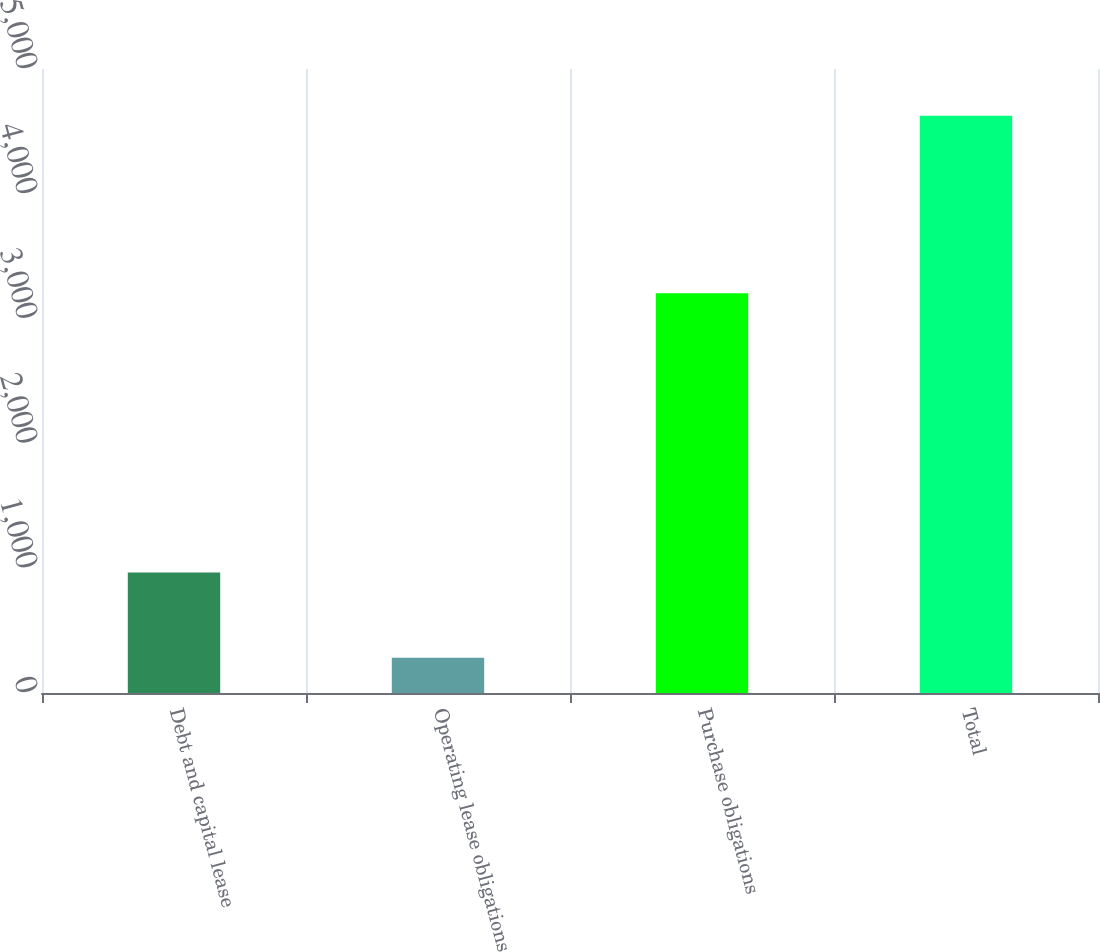Convert chart. <chart><loc_0><loc_0><loc_500><loc_500><bar_chart><fcel>Debt and capital lease<fcel>Operating lease obligations<fcel>Purchase obligations<fcel>Total<nl><fcel>966<fcel>283<fcel>3204<fcel>4625<nl></chart> 